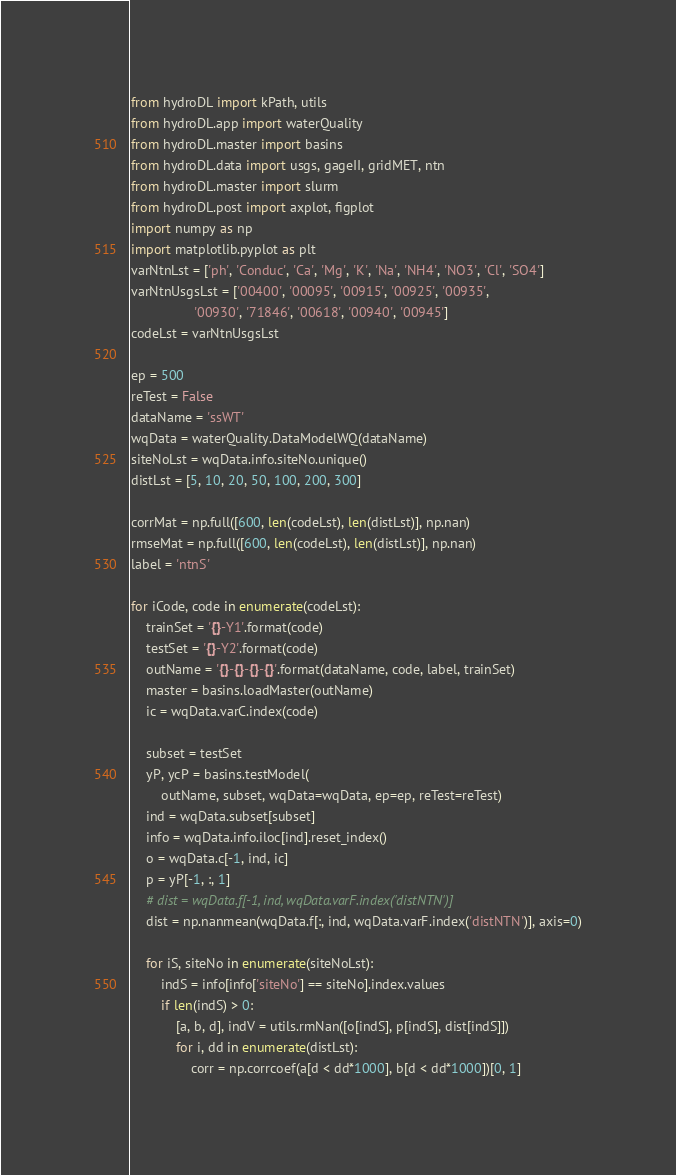Convert code to text. <code><loc_0><loc_0><loc_500><loc_500><_Python_>from hydroDL import kPath, utils
from hydroDL.app import waterQuality
from hydroDL.master import basins
from hydroDL.data import usgs, gageII, gridMET, ntn
from hydroDL.master import slurm
from hydroDL.post import axplot, figplot
import numpy as np
import matplotlib.pyplot as plt
varNtnLst = ['ph', 'Conduc', 'Ca', 'Mg', 'K', 'Na', 'NH4', 'NO3', 'Cl', 'SO4']
varNtnUsgsLst = ['00400', '00095', '00915', '00925', '00935',
                 '00930', '71846', '00618', '00940', '00945']
codeLst = varNtnUsgsLst

ep = 500
reTest = False
dataName = 'ssWT'
wqData = waterQuality.DataModelWQ(dataName)
siteNoLst = wqData.info.siteNo.unique()
distLst = [5, 10, 20, 50, 100, 200, 300]

corrMat = np.full([600, len(codeLst), len(distLst)], np.nan)
rmseMat = np.full([600, len(codeLst), len(distLst)], np.nan)
label = 'ntnS'

for iCode, code in enumerate(codeLst):
    trainSet = '{}-Y1'.format(code)
    testSet = '{}-Y2'.format(code)
    outName = '{}-{}-{}-{}'.format(dataName, code, label, trainSet)
    master = basins.loadMaster(outName)
    ic = wqData.varC.index(code)

    subset = testSet
    yP, ycP = basins.testModel(
        outName, subset, wqData=wqData, ep=ep, reTest=reTest)
    ind = wqData.subset[subset]
    info = wqData.info.iloc[ind].reset_index()
    o = wqData.c[-1, ind, ic]
    p = yP[-1, :, 1]
    # dist = wqData.f[-1, ind, wqData.varF.index('distNTN')]
    dist = np.nanmean(wqData.f[:, ind, wqData.varF.index('distNTN')], axis=0)

    for iS, siteNo in enumerate(siteNoLst):
        indS = info[info['siteNo'] == siteNo].index.values
        if len(indS) > 0:
            [a, b, d], indV = utils.rmNan([o[indS], p[indS], dist[indS]])
            for i, dd in enumerate(distLst):
                corr = np.corrcoef(a[d < dd*1000], b[d < dd*1000])[0, 1]</code> 